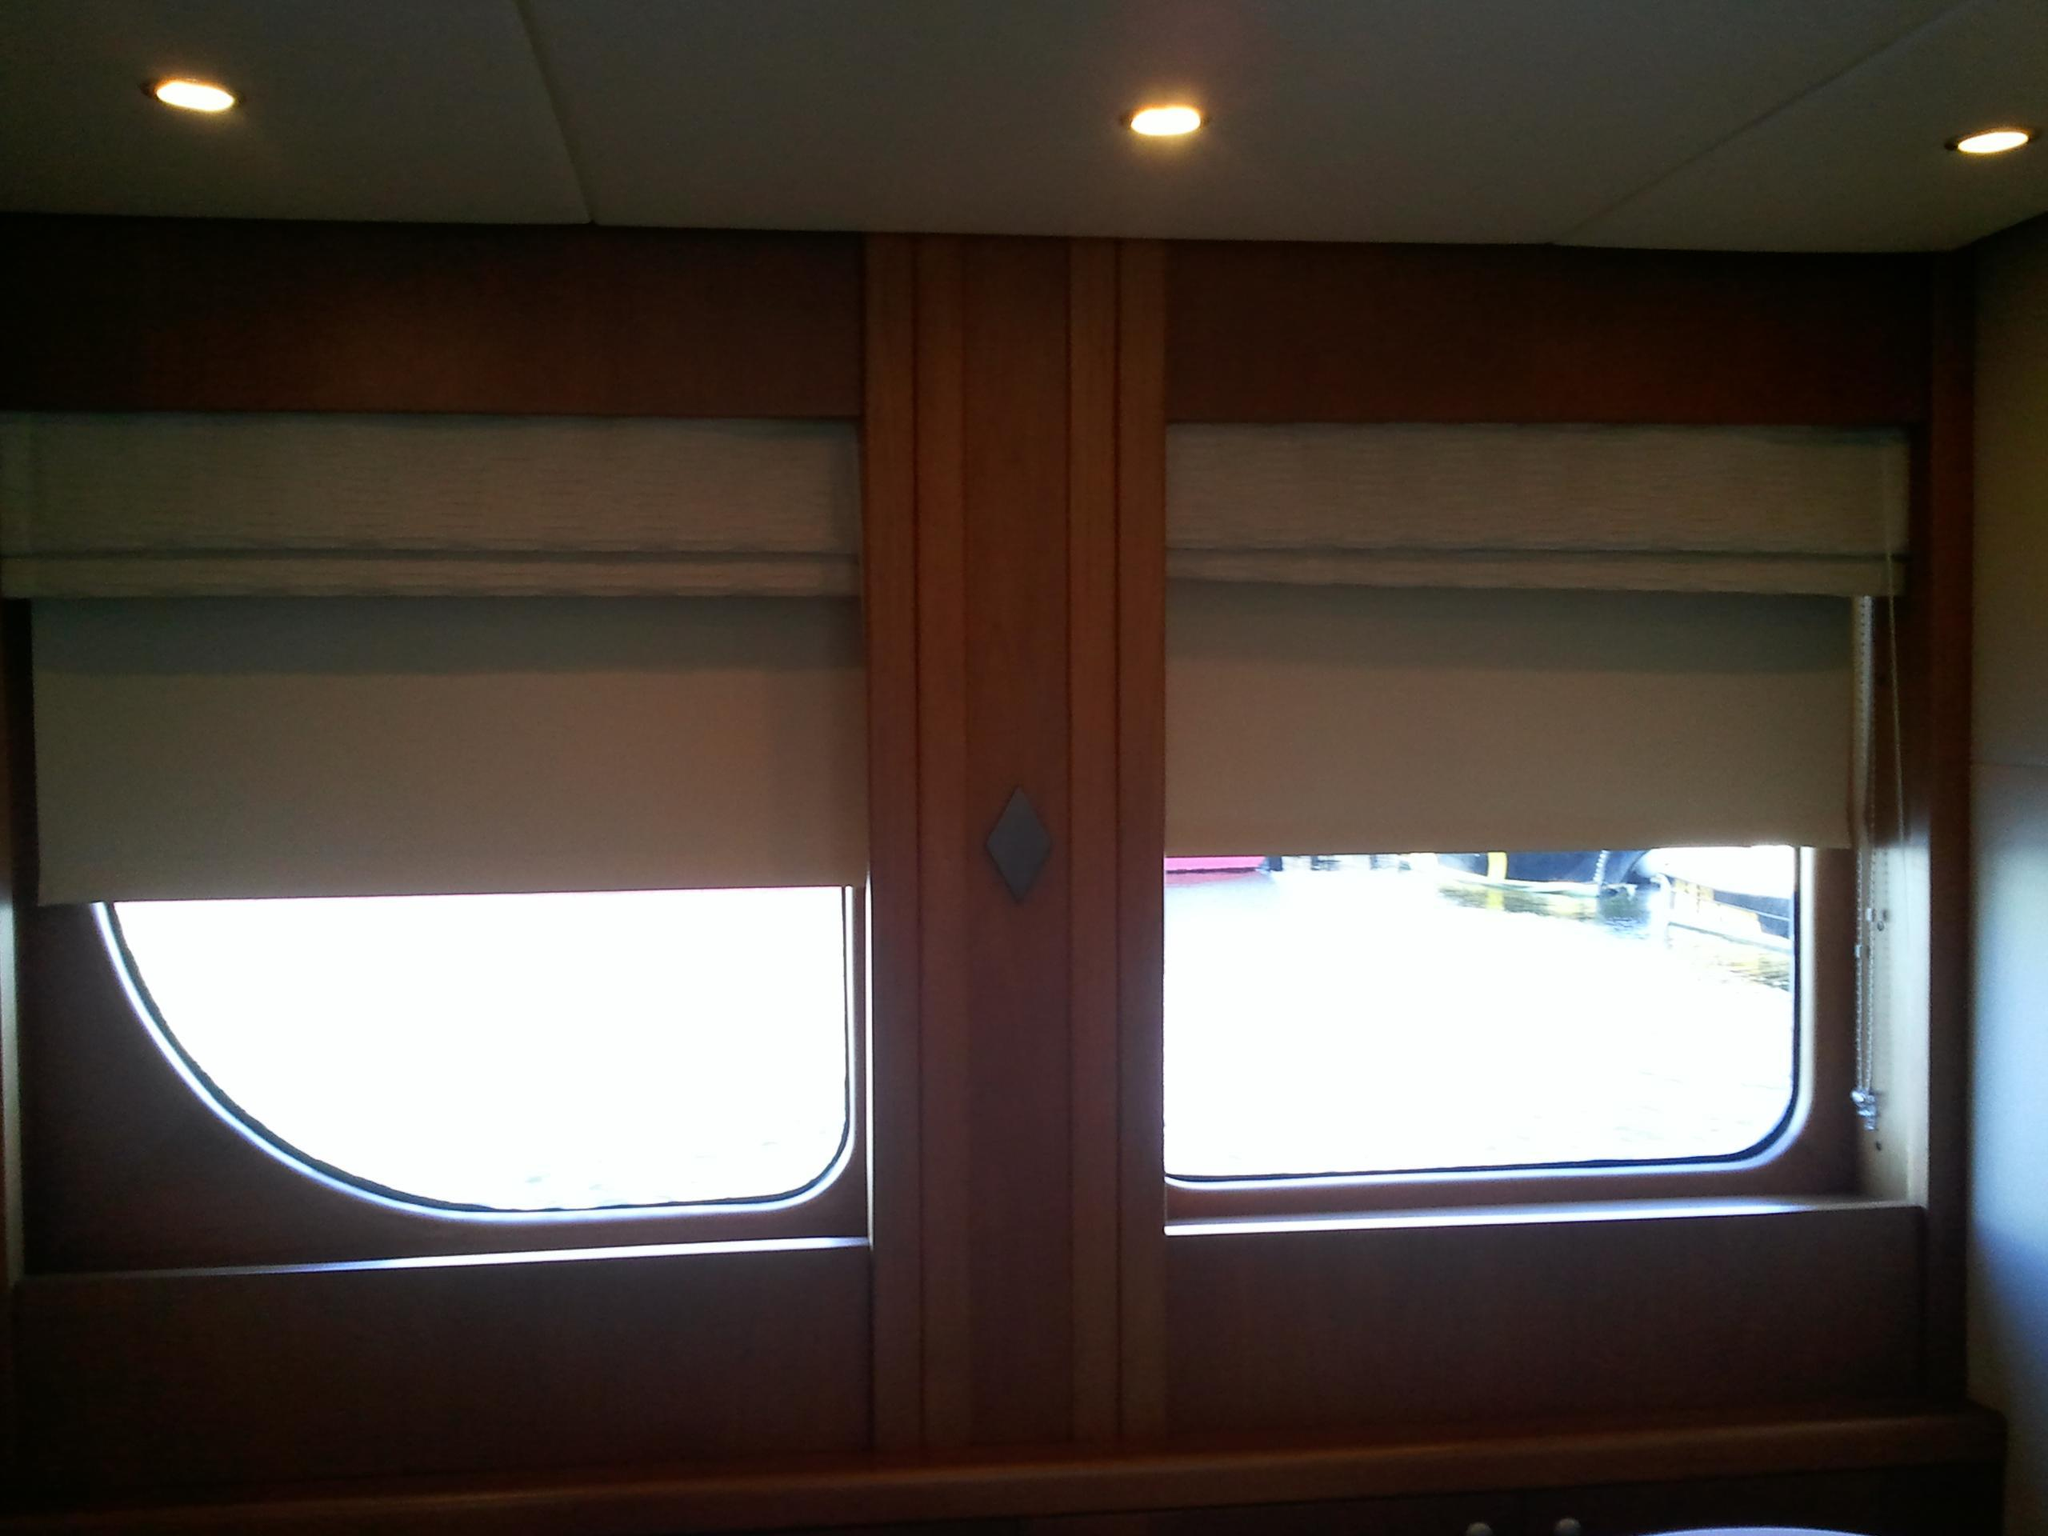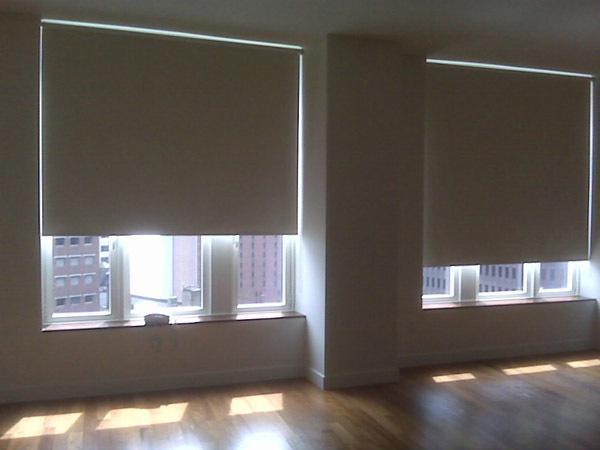The first image is the image on the left, the second image is the image on the right. Assess this claim about the two images: "There is a total of five windows.". Correct or not? Answer yes or no. No. The first image is the image on the left, the second image is the image on the right. Considering the images on both sides, is "The window area in the image on the left has lights that are switched on." valid? Answer yes or no. Yes. 